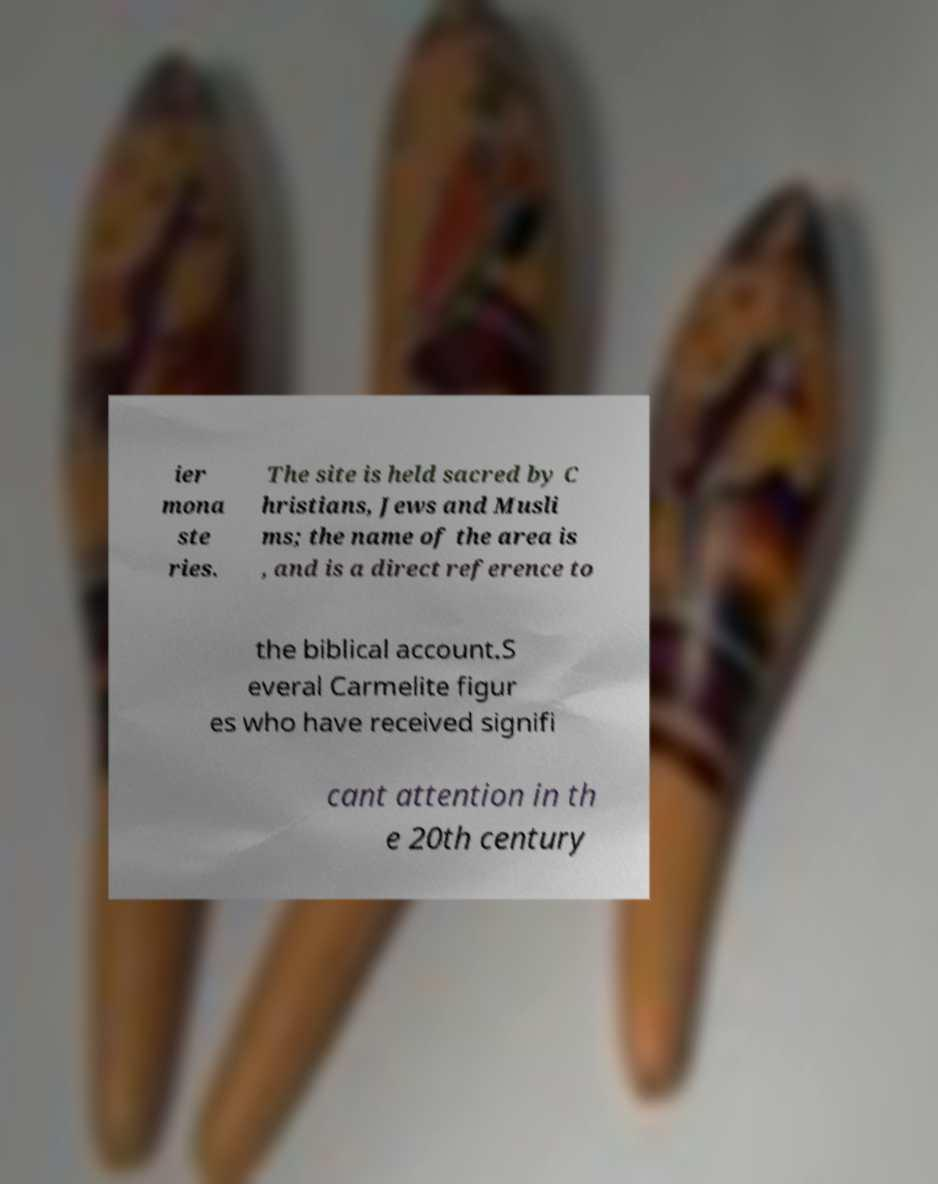Can you accurately transcribe the text from the provided image for me? ier mona ste ries. The site is held sacred by C hristians, Jews and Musli ms; the name of the area is , and is a direct reference to the biblical account.S everal Carmelite figur es who have received signifi cant attention in th e 20th century 